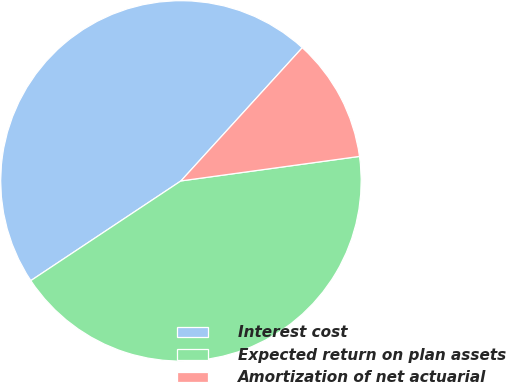Convert chart. <chart><loc_0><loc_0><loc_500><loc_500><pie_chart><fcel>Interest cost<fcel>Expected return on plan assets<fcel>Amortization of net actuarial<nl><fcel>46.09%<fcel>42.84%<fcel>11.07%<nl></chart> 